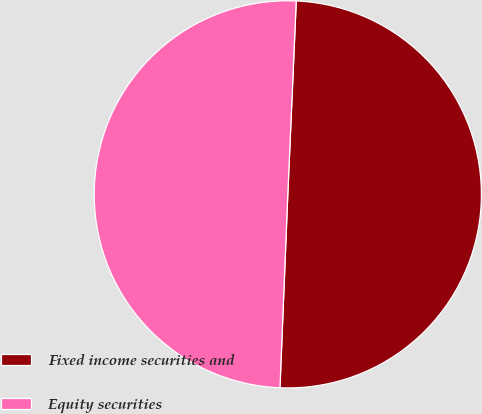Convert chart to OTSL. <chart><loc_0><loc_0><loc_500><loc_500><pie_chart><fcel>Fixed income securities and<fcel>Equity securities<nl><fcel>49.95%<fcel>50.05%<nl></chart> 